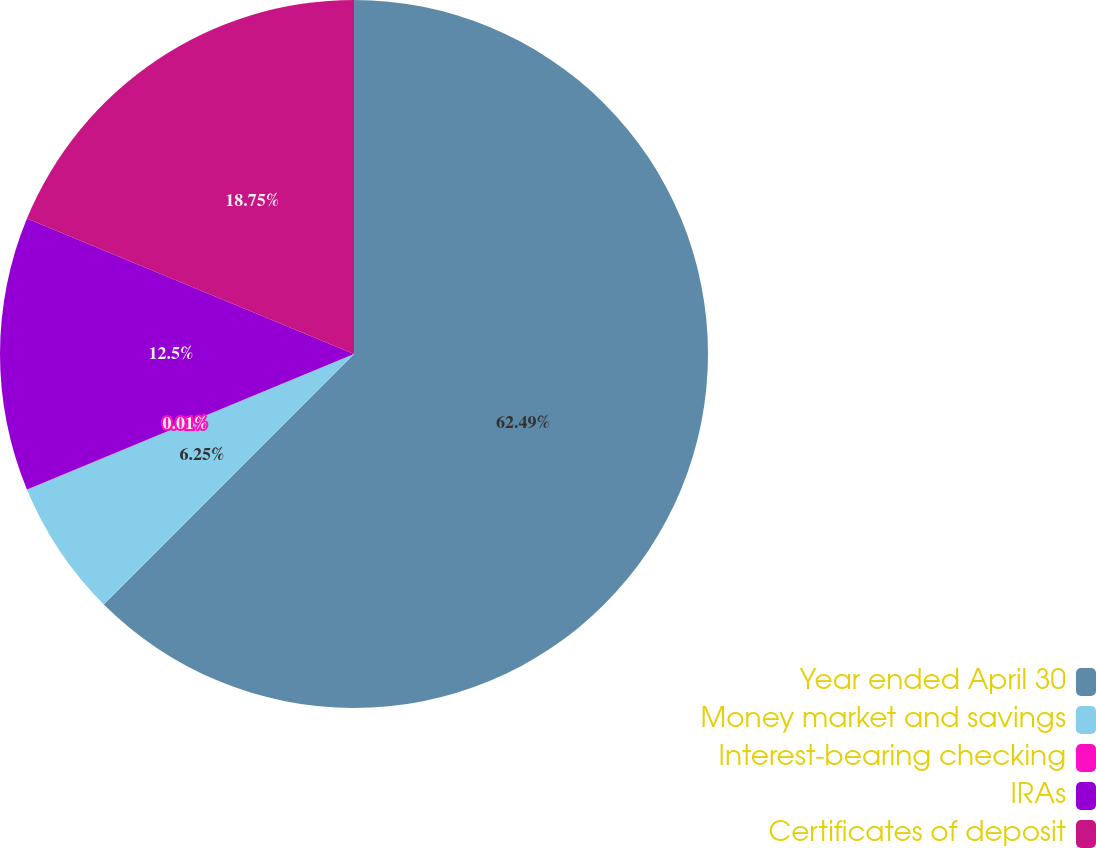<chart> <loc_0><loc_0><loc_500><loc_500><pie_chart><fcel>Year ended April 30<fcel>Money market and savings<fcel>Interest-bearing checking<fcel>IRAs<fcel>Certificates of deposit<nl><fcel>62.49%<fcel>6.25%<fcel>0.01%<fcel>12.5%<fcel>18.75%<nl></chart> 